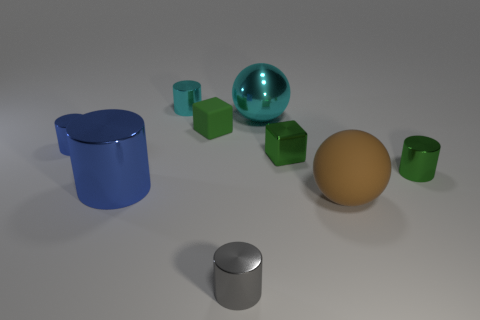Could you describe the lighting in this scene? The lighting in the scene seems to come from above as evidenced by the soft shadows cast directly under the objects. The shadows are soft-edged, which suggests a diffuse light source, possibly simulating an overcast sky or a softbox in a studio. The way the light reflects off the shiny surfaces also indicates that the main light source is broad and not overly directional. What purpose might this image serve? This image could serve several purposes: it could be an artistic composition intended to showcase contrasts in color, material, and texture. It may also serve an educational purpose, illustrating the effects of lighting on different surfaces. Lastly, it may be a test render for a 3D modeling software, highlighting the program's ability to render diverse materials and reflections. 